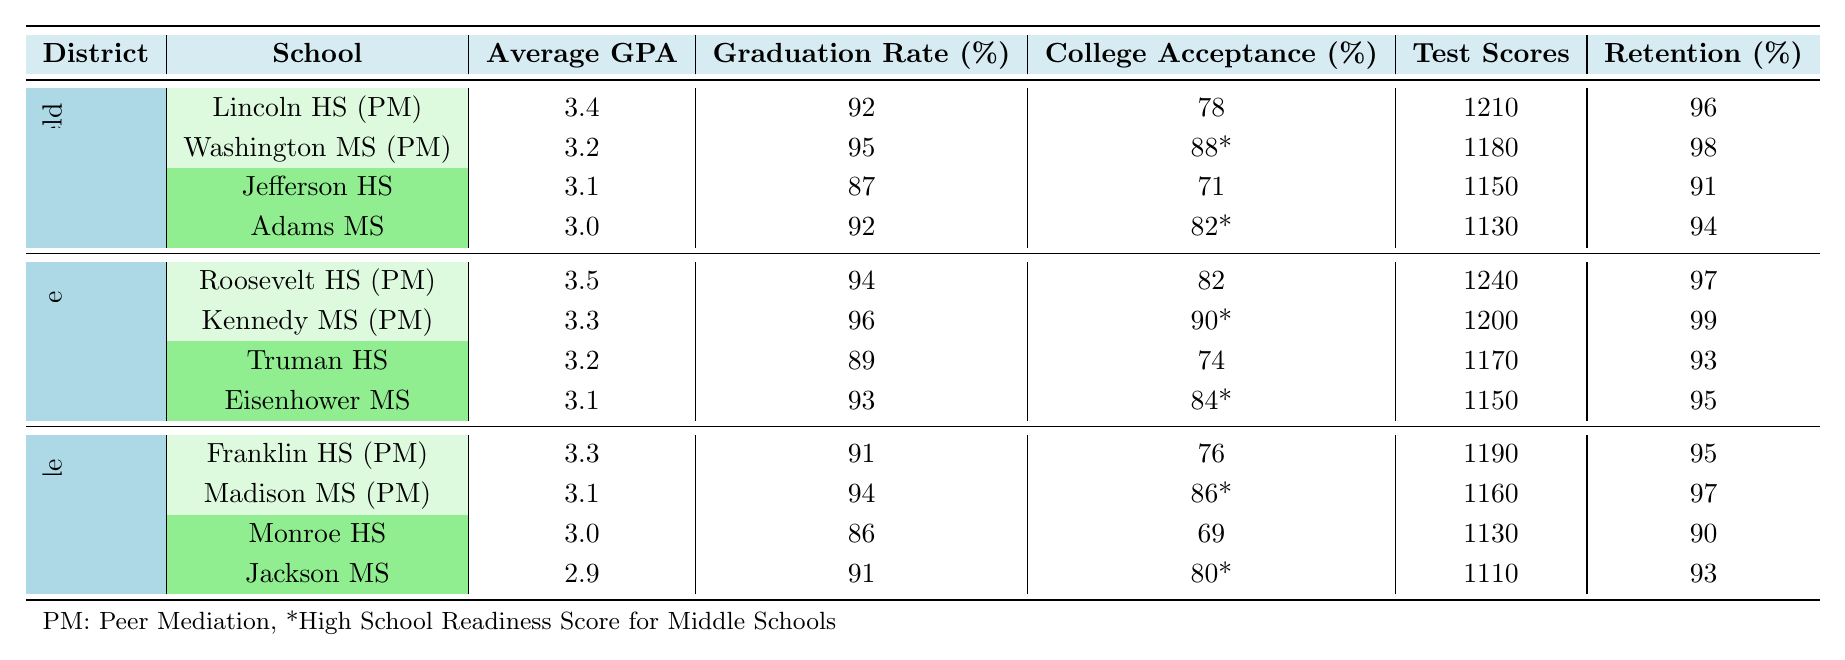What is the Average GPA for Lincoln High School? The table shows the Average GPA for Lincoln High School under the "Schools with Peer Mediation" section listed as 3.4.
Answer: 3.4 What is the Graduation Rate for Truman High School? According to the table, the Graduation Rate for Truman High School, which is in the "Schools without Peer Mediation" section, is listed as 89%.
Answer: 89 Which school has the highest College Acceptance Rate in the table? Comparing the College Acceptance Rates from the schools listed, Roosevelt High School has the highest rate at 82%.
Answer: 82 What is the average Student Retention Rate for schools with Peer Mediation in Springfield School District? For Springfield, the Student Retention Rates for schools with Peer Mediation are 96% (Lincoln High) and 98% (Washington Middle). Therefore, the average is (96 + 98) / 2 = 97%.
Answer: 97 Which school has the lowest GPA among those without Peer Mediation? The table indicates that Jackson Middle School has the lowest Average GPA among schools without Peer Mediation, at 2.9.
Answer: 2.9 Are the Standardized Test Scores for Kennedy Middle School higher than those for Adams Middle School? Yes, Kennedy Middle School has a Standardized Test Score of 1200, while Adams Middle School has a score of 1130, making it higher.
Answer: Yes What is the difference in Graduation Rates between schools with and without Peer Mediation in Riverside County? Franklin High School (PM) has a Graduation Rate of 91% and Monroe High School (no PM) has a rate of 86%. The difference is 91 - 86 = 5%.
Answer: 5 What is the average Standardized Test Score for schools in Oakville School District? For Oakville, the scores are 1240 (Roosevelt HS) and 1200 (Kennedy MS) with a total of 2440. The average is 2440 / 2 = 1220.
Answer: 1220 Which middle school has the highest High School Readiness Score, and what is that score? The table indicates Kennedy Middle School has the highest High School Readiness Score at 90.
Answer: 90 Is the average GPA of schools with Peer Mediation in Springfield higher than that of schools without Peer Mediation? The average GPA for Peer Mediation schools in Springfield is (3.4 + 3.2) / 2 = 3.3, while for schools without it it is (3.1 + 3.0) / 2 = 3.05. Thus, 3.3 > 3.05.
Answer: Yes What is the overall average Graduation Rate for all schools listed in the table? The Graduation Rates are 92, 95, 87, 92, 94, 96, 89, 93, 91, 94, 86, 91. Summing these gives 1090, and dividing by 12 results in approximately 90.83%.
Answer: 90.83 